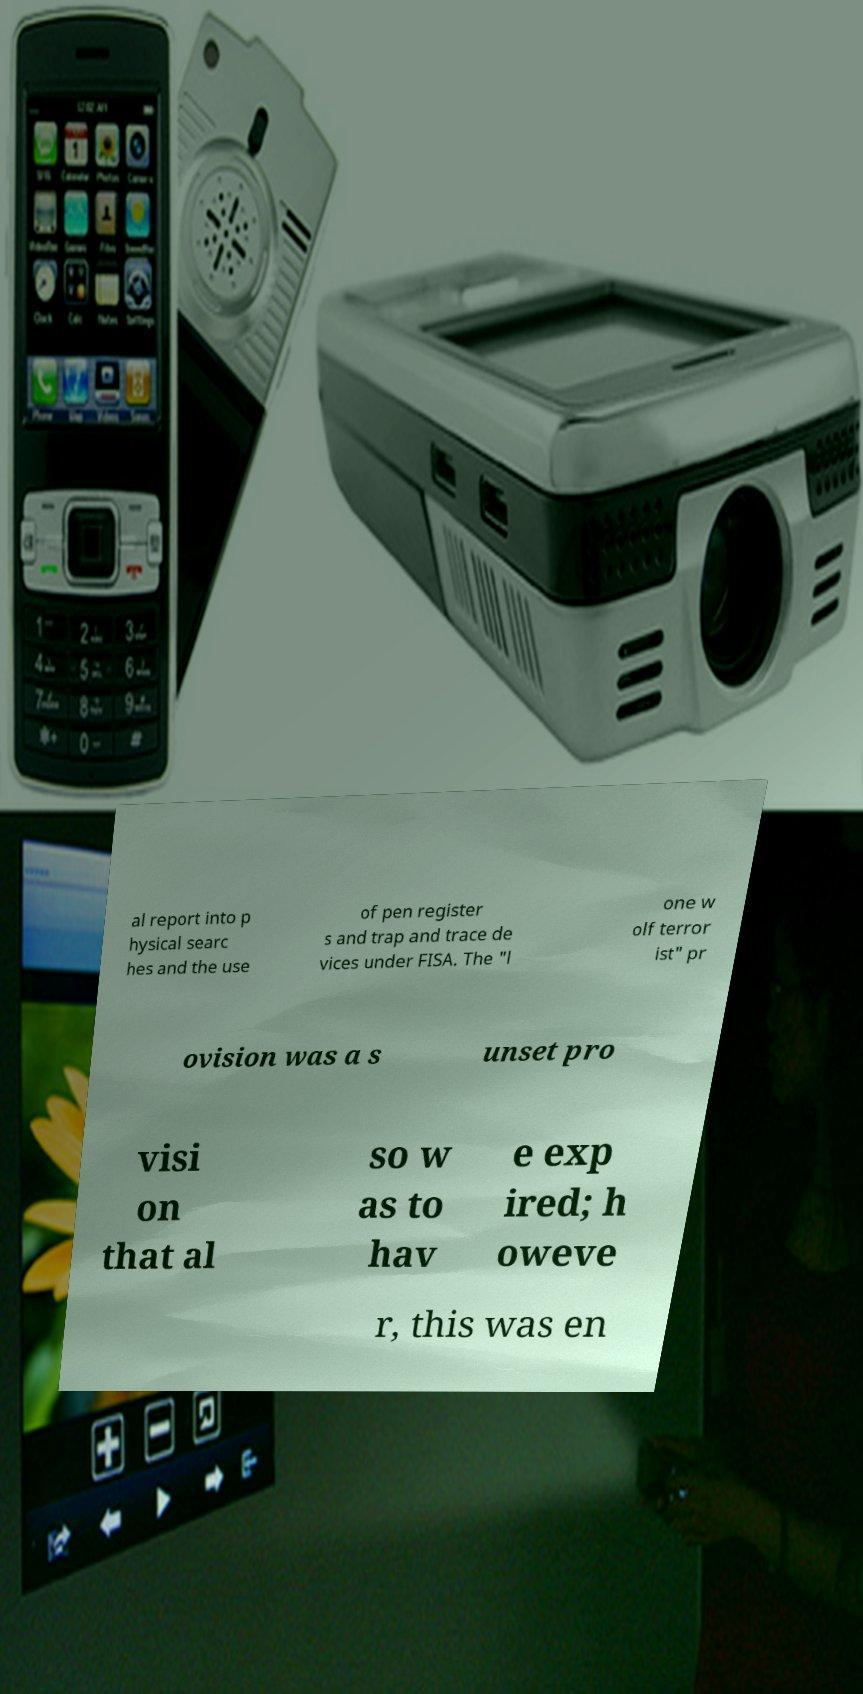I need the written content from this picture converted into text. Can you do that? al report into p hysical searc hes and the use of pen register s and trap and trace de vices under FISA. The "l one w olf terror ist" pr ovision was a s unset pro visi on that al so w as to hav e exp ired; h oweve r, this was en 